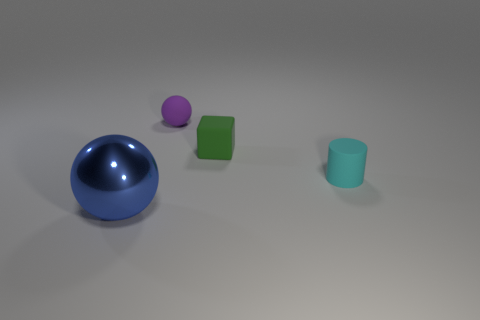How big is the sphere that is in front of the rubber cube?
Your answer should be compact. Large. What size is the other metal object that is the same shape as the tiny purple object?
Your answer should be very brief. Large. Do the large thing and the thing that is behind the tiny matte cube have the same shape?
Your answer should be very brief. Yes. There is a thing to the left of the sphere that is behind the small cyan rubber cylinder; how big is it?
Your answer should be very brief. Large. Is the number of green matte blocks that are on the left side of the rubber block the same as the number of things that are left of the small purple sphere?
Offer a very short reply. No. There is a small rubber object that is the same shape as the big metallic thing; what is its color?
Keep it short and to the point. Purple. There is a small matte thing that is on the left side of the tiny green object; is its shape the same as the large object?
Make the answer very short. Yes. There is a thing to the left of the ball behind the ball on the left side of the tiny purple matte object; what is its shape?
Ensure brevity in your answer.  Sphere. The blue metal object is what size?
Ensure brevity in your answer.  Large. The small sphere that is the same material as the green thing is what color?
Your answer should be compact. Purple. 